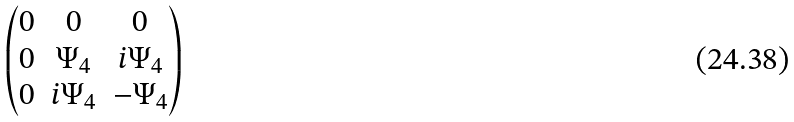Convert formula to latex. <formula><loc_0><loc_0><loc_500><loc_500>\begin{pmatrix} 0 & 0 & 0 \\ 0 & \Psi _ { 4 } & i \Psi _ { 4 } \\ 0 & i \Psi _ { 4 } & - \Psi _ { 4 } \end{pmatrix}</formula> 